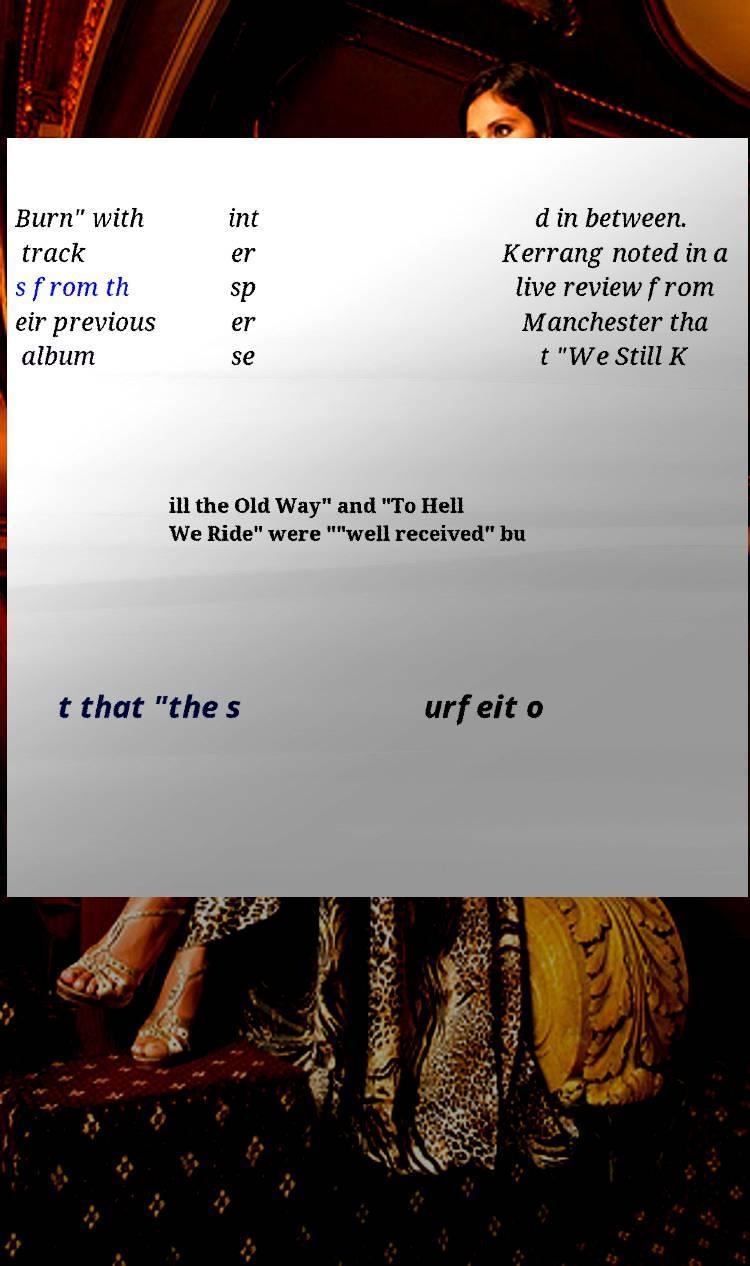Can you accurately transcribe the text from the provided image for me? Burn" with track s from th eir previous album int er sp er se d in between. Kerrang noted in a live review from Manchester tha t "We Still K ill the Old Way" and "To Hell We Ride" were ""well received" bu t that "the s urfeit o 